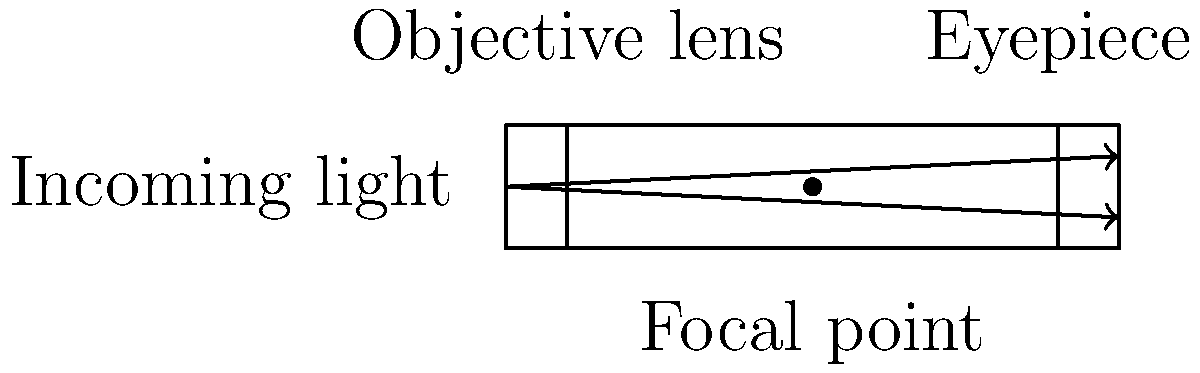In a refracting telescope, what is the primary function of the objective lens in magnifying celestial objects? To understand how a refracting telescope magnifies celestial objects, let's break down its structure and function:

1. A refracting telescope consists of two main lenses: the objective lens and the eyepiece.

2. The objective lens is the larger lens at the front of the telescope. Its primary functions are:
   a) To gather light from distant objects
   b) To bend (refract) this light to form an image

3. The amount of light gathered is proportional to the area of the objective lens. A larger lens collects more light, allowing for viewing of fainter objects.

4. As the light passes through the objective lens, it is bent inwards and converges at a point called the focal point.

5. This creates a real, inverted image of the celestial object inside the telescope tube.

6. The eyepiece then acts as a magnifying glass, enlarging this image for the observer.

7. The magnification of the telescope is determined by the ratio of the focal lengths of the objective lens and the eyepiece:

   $$ \text{Magnification} = \frac{\text{Focal length of objective lens}}{\text{Focal length of eyepiece}} $$

8. The objective lens's focal length is typically much longer than that of the eyepiece, resulting in magnification.

In summary, the objective lens's primary function in magnifying celestial objects is to gather light and form an initial image, which is then further magnified by the eyepiece.
Answer: Gather light and form initial image 